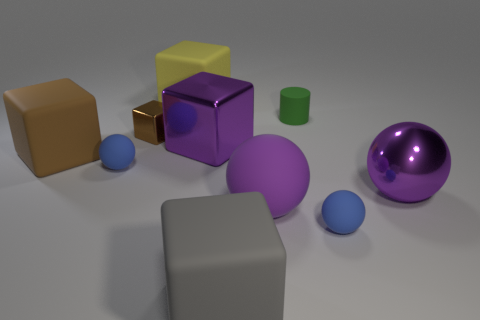How many other things are there of the same size as the brown rubber cube?
Offer a terse response. 5. Does the large gray cube have the same material as the purple ball to the right of the tiny green object?
Ensure brevity in your answer.  No. What number of objects are blue spheres that are behind the big purple rubber object or brown cubes to the right of the large brown matte block?
Ensure brevity in your answer.  2. What color is the cylinder?
Your answer should be very brief. Green. Are there fewer large purple objects to the left of the big yellow matte cube than big purple metal blocks?
Offer a terse response. Yes. Is there anything else that is the same shape as the green matte thing?
Your response must be concise. No. Is there a tiny gray object?
Offer a very short reply. No. Are there fewer spheres than green things?
Give a very brief answer. No. How many big purple cubes are the same material as the large yellow block?
Ensure brevity in your answer.  0. What color is the large ball that is the same material as the big gray block?
Ensure brevity in your answer.  Purple. 